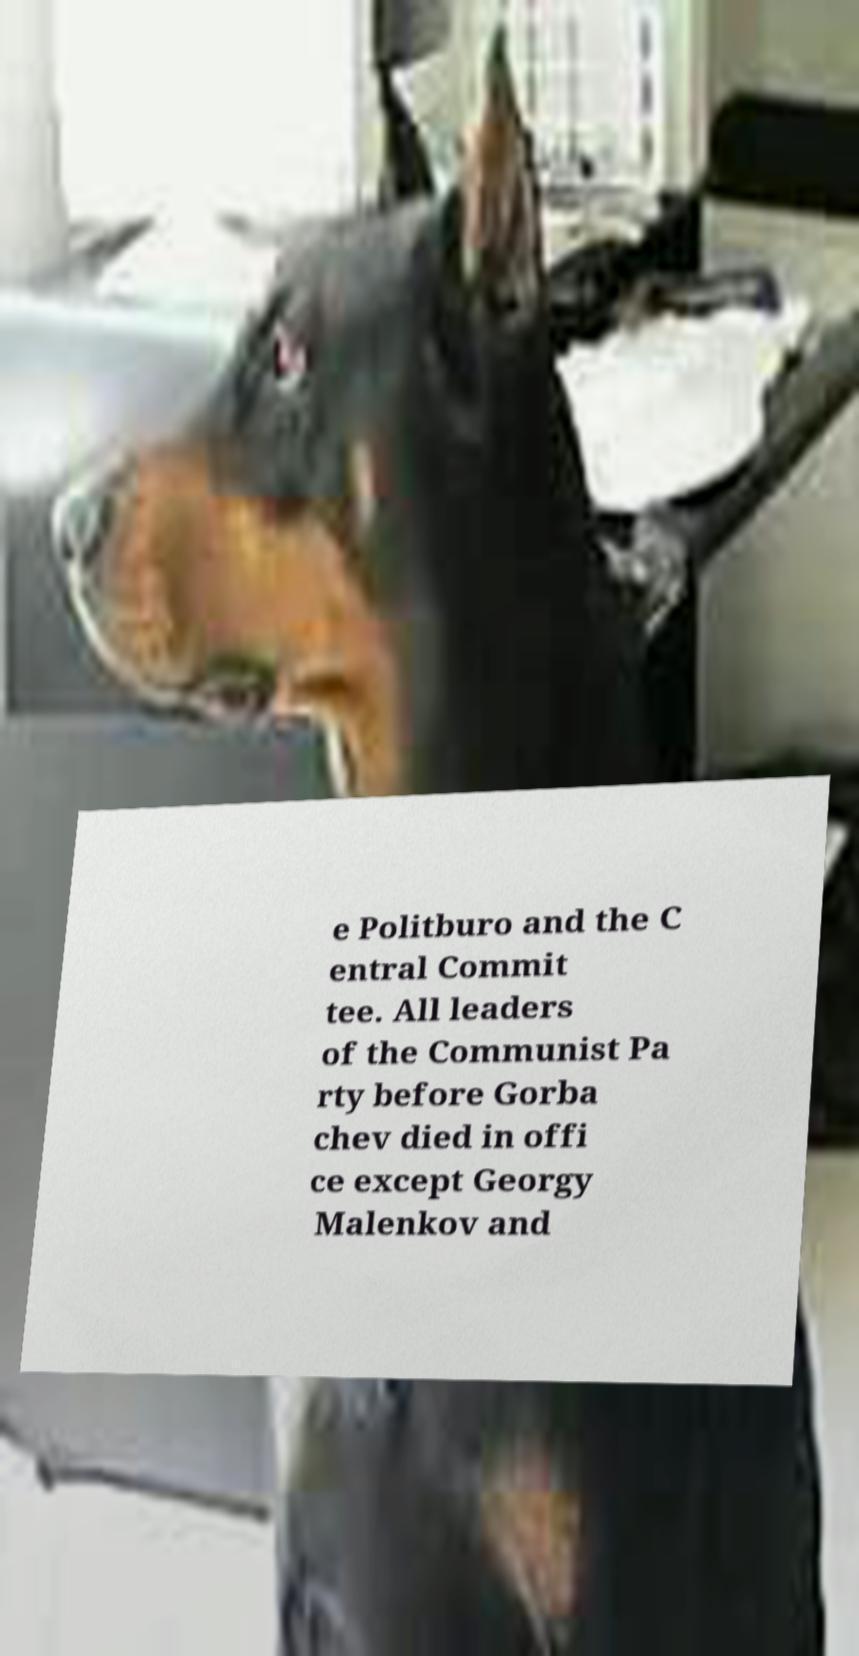Could you assist in decoding the text presented in this image and type it out clearly? e Politburo and the C entral Commit tee. All leaders of the Communist Pa rty before Gorba chev died in offi ce except Georgy Malenkov and 